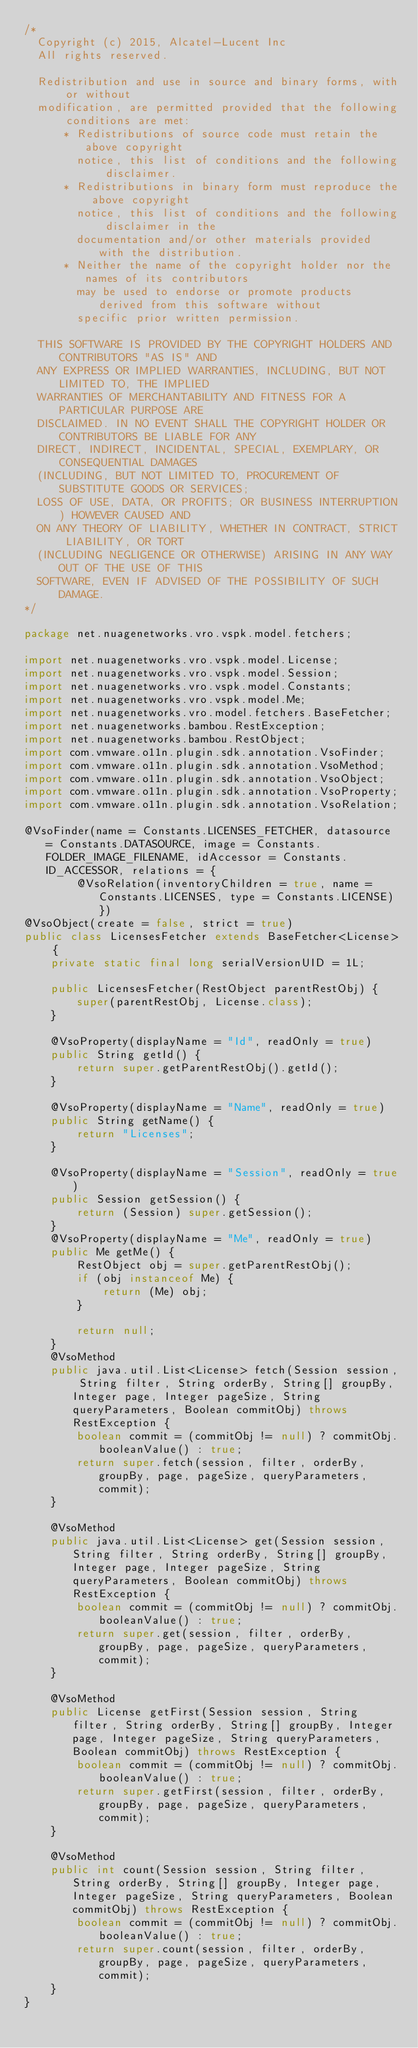<code> <loc_0><loc_0><loc_500><loc_500><_Java_>/*
  Copyright (c) 2015, Alcatel-Lucent Inc
  All rights reserved.

  Redistribution and use in source and binary forms, with or without
  modification, are permitted provided that the following conditions are met:
      * Redistributions of source code must retain the above copyright
        notice, this list of conditions and the following disclaimer.
      * Redistributions in binary form must reproduce the above copyright
        notice, this list of conditions and the following disclaimer in the
        documentation and/or other materials provided with the distribution.
      * Neither the name of the copyright holder nor the names of its contributors
        may be used to endorse or promote products derived from this software without
        specific prior written permission.

  THIS SOFTWARE IS PROVIDED BY THE COPYRIGHT HOLDERS AND CONTRIBUTORS "AS IS" AND
  ANY EXPRESS OR IMPLIED WARRANTIES, INCLUDING, BUT NOT LIMITED TO, THE IMPLIED
  WARRANTIES OF MERCHANTABILITY AND FITNESS FOR A PARTICULAR PURPOSE ARE
  DISCLAIMED. IN NO EVENT SHALL THE COPYRIGHT HOLDER OR CONTRIBUTORS BE LIABLE FOR ANY
  DIRECT, INDIRECT, INCIDENTAL, SPECIAL, EXEMPLARY, OR CONSEQUENTIAL DAMAGES
  (INCLUDING, BUT NOT LIMITED TO, PROCUREMENT OF SUBSTITUTE GOODS OR SERVICES;
  LOSS OF USE, DATA, OR PROFITS; OR BUSINESS INTERRUPTION) HOWEVER CAUSED AND
  ON ANY THEORY OF LIABILITY, WHETHER IN CONTRACT, STRICT LIABILITY, OR TORT
  (INCLUDING NEGLIGENCE OR OTHERWISE) ARISING IN ANY WAY OUT OF THE USE OF THIS
  SOFTWARE, EVEN IF ADVISED OF THE POSSIBILITY OF SUCH DAMAGE.
*/

package net.nuagenetworks.vro.vspk.model.fetchers;

import net.nuagenetworks.vro.vspk.model.License;
import net.nuagenetworks.vro.vspk.model.Session;
import net.nuagenetworks.vro.vspk.model.Constants;
import net.nuagenetworks.vro.vspk.model.Me;
import net.nuagenetworks.vro.model.fetchers.BaseFetcher;
import net.nuagenetworks.bambou.RestException;
import net.nuagenetworks.bambou.RestObject;
import com.vmware.o11n.plugin.sdk.annotation.VsoFinder;
import com.vmware.o11n.plugin.sdk.annotation.VsoMethod;
import com.vmware.o11n.plugin.sdk.annotation.VsoObject;
import com.vmware.o11n.plugin.sdk.annotation.VsoProperty;
import com.vmware.o11n.plugin.sdk.annotation.VsoRelation;

@VsoFinder(name = Constants.LICENSES_FETCHER, datasource = Constants.DATASOURCE, image = Constants.FOLDER_IMAGE_FILENAME, idAccessor = Constants.ID_ACCESSOR, relations = {
        @VsoRelation(inventoryChildren = true, name = Constants.LICENSES, type = Constants.LICENSE) })
@VsoObject(create = false, strict = true)
public class LicensesFetcher extends BaseFetcher<License> {
    private static final long serialVersionUID = 1L;

    public LicensesFetcher(RestObject parentRestObj) {
        super(parentRestObj, License.class);
    }

    @VsoProperty(displayName = "Id", readOnly = true)
    public String getId() {
        return super.getParentRestObj().getId();
    }

    @VsoProperty(displayName = "Name", readOnly = true)
    public String getName() {
        return "Licenses";
    }

    @VsoProperty(displayName = "Session", readOnly = true)
    public Session getSession() {
        return (Session) super.getSession();
    }
    @VsoProperty(displayName = "Me", readOnly = true)
    public Me getMe() {
        RestObject obj = super.getParentRestObj();
        if (obj instanceof Me) {
            return (Me) obj;
        }
        
        return null;
    }
    @VsoMethod
    public java.util.List<License> fetch(Session session, String filter, String orderBy, String[] groupBy, Integer page, Integer pageSize, String queryParameters, Boolean commitObj) throws RestException {
        boolean commit = (commitObj != null) ? commitObj.booleanValue() : true;
        return super.fetch(session, filter, orderBy, groupBy, page, pageSize, queryParameters, commit);
    }

    @VsoMethod
    public java.util.List<License> get(Session session, String filter, String orderBy, String[] groupBy, Integer page, Integer pageSize, String queryParameters, Boolean commitObj) throws RestException {
        boolean commit = (commitObj != null) ? commitObj.booleanValue() : true;
        return super.get(session, filter, orderBy, groupBy, page, pageSize, queryParameters, commit);
    }

    @VsoMethod
    public License getFirst(Session session, String filter, String orderBy, String[] groupBy, Integer page, Integer pageSize, String queryParameters, Boolean commitObj) throws RestException {
        boolean commit = (commitObj != null) ? commitObj.booleanValue() : true;
        return super.getFirst(session, filter, orderBy, groupBy, page, pageSize, queryParameters, commit);
    }

    @VsoMethod
    public int count(Session session, String filter, String orderBy, String[] groupBy, Integer page, Integer pageSize, String queryParameters, Boolean commitObj) throws RestException {
        boolean commit = (commitObj != null) ? commitObj.booleanValue() : true;
        return super.count(session, filter, orderBy, groupBy, page, pageSize, queryParameters, commit);
    }
}</code> 